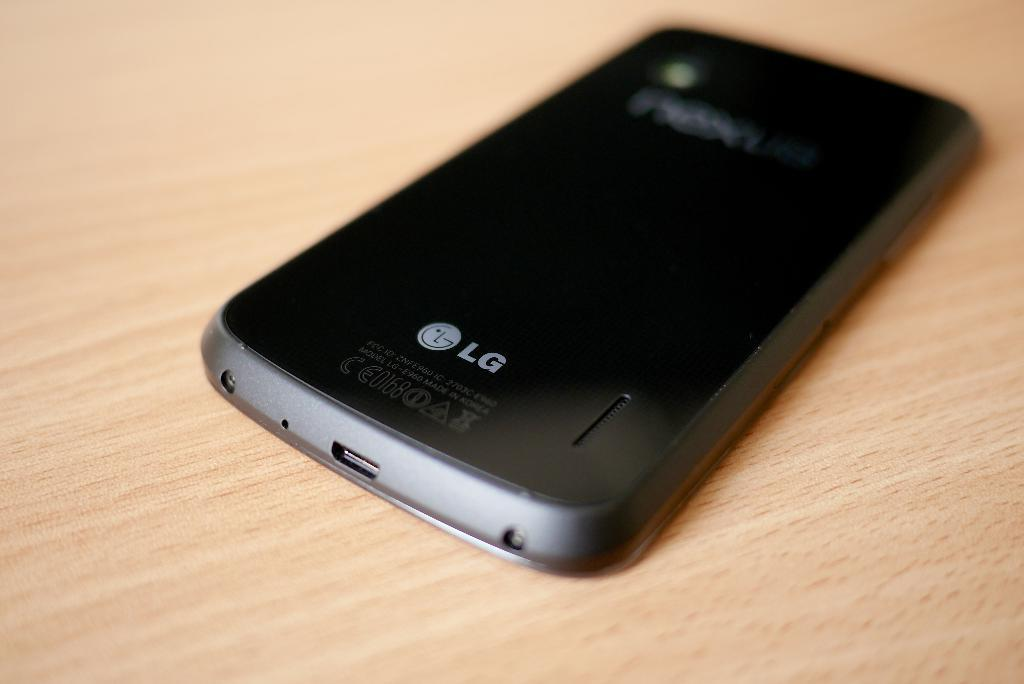<image>
Give a short and clear explanation of the subsequent image. An LG brand cellphone facing down on a wood table 